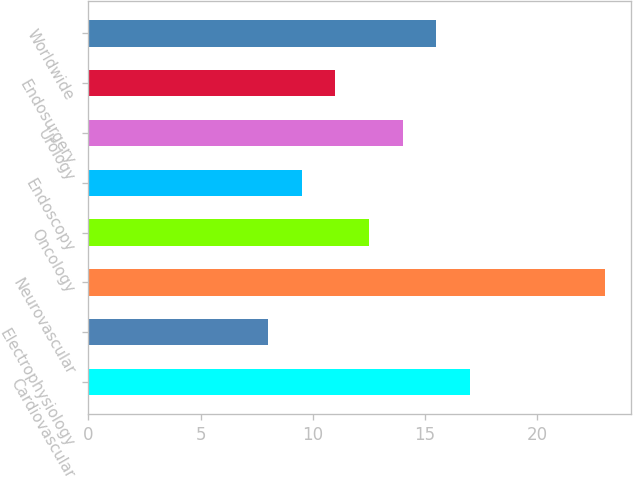Convert chart to OTSL. <chart><loc_0><loc_0><loc_500><loc_500><bar_chart><fcel>Cardiovascular<fcel>Electrophysiology<fcel>Neurovascular<fcel>Oncology<fcel>Endoscopy<fcel>Urology<fcel>Endosurgery<fcel>Worldwide<nl><fcel>17<fcel>8<fcel>23<fcel>12.5<fcel>9.5<fcel>14<fcel>11<fcel>15.5<nl></chart> 